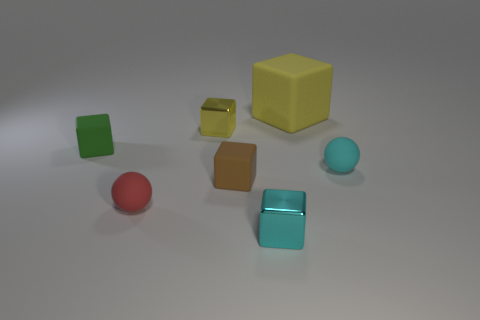Subtract all cyan blocks. How many blocks are left? 4 Subtract 1 blocks. How many blocks are left? 4 Subtract all big rubber blocks. How many blocks are left? 4 Subtract all cyan cubes. Subtract all red cylinders. How many cubes are left? 4 Add 2 shiny blocks. How many objects exist? 9 Subtract all blocks. How many objects are left? 2 Add 3 brown matte blocks. How many brown matte blocks are left? 4 Add 7 brown rubber objects. How many brown rubber objects exist? 8 Subtract 0 green spheres. How many objects are left? 7 Subtract all green matte things. Subtract all tiny metallic objects. How many objects are left? 4 